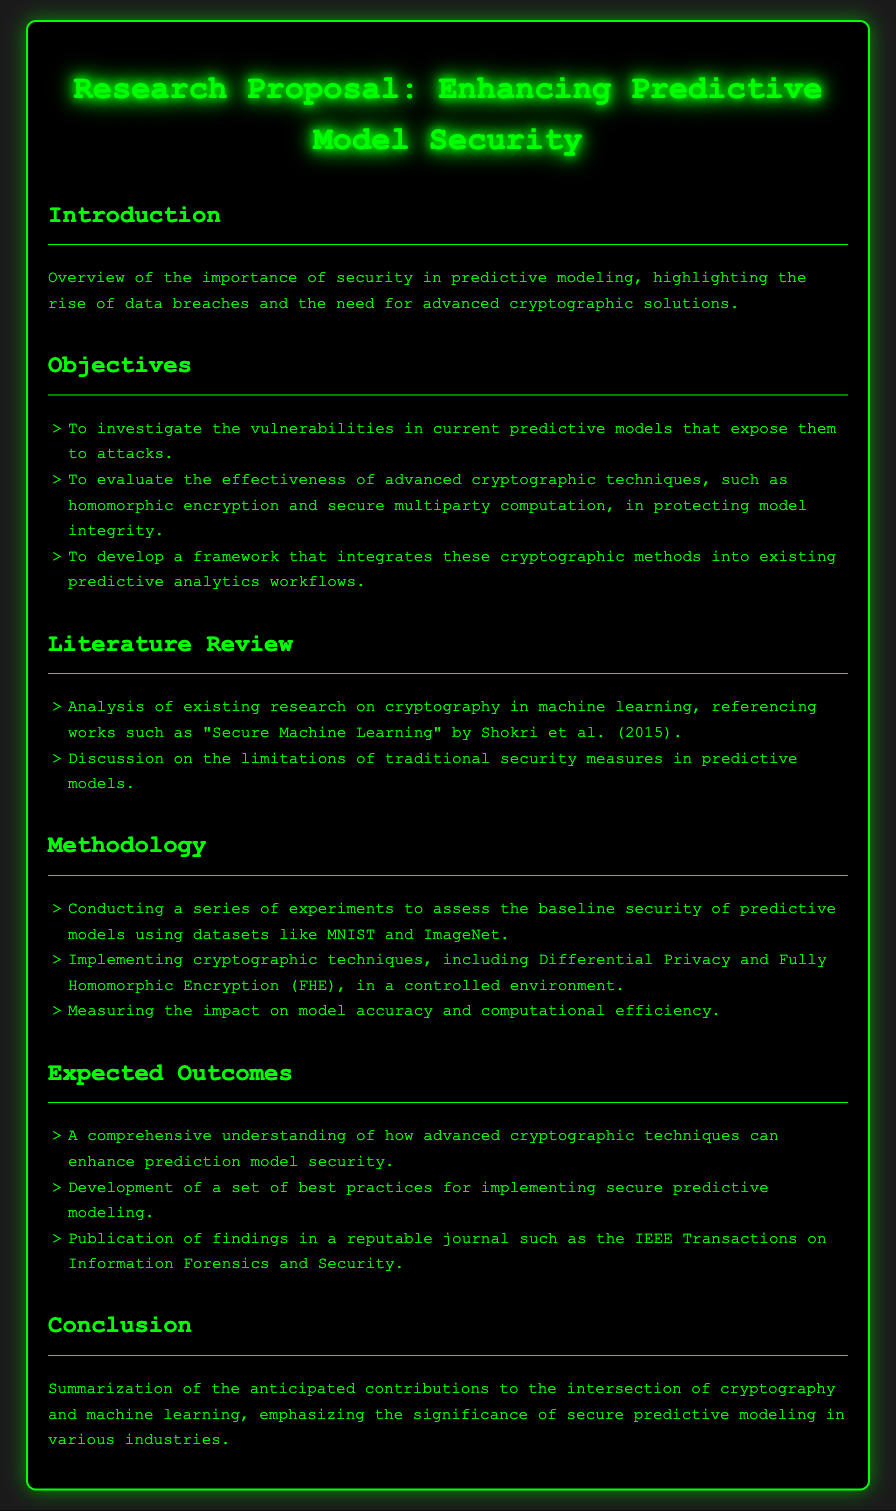What are the three main objectives of the research proposal? The objectives listed in the document include investigating vulnerabilities, evaluating effectiveness of cryptographic techniques, and developing a framework for integration.
Answer: Investigate vulnerabilities, evaluate effectiveness, develop a framework Which advanced cryptographic techniques are mentioned in the proposal? The document states specific techniques that will be evaluated to protect model integrity.
Answer: Homomorphic encryption, secure multiparty computation What datasets will be used in the experiments? The proposal outlines specific datasets for assessing baseline security of predictive models.
Answer: MNIST, ImageNet What is one expected outcome of the research? The document provides details on various results that the research aims to achieve, focusing on the understanding of security enhancements.
Answer: A comprehensive understanding of enhancements Which journal is mentioned for potential publication of findings? The proposal states the intended journal for submitting the research outcomes.
Answer: IEEE Transactions on Information Forensics and Security What is the primary focus of the literature review? The literature review section highlights the analysis conducted on current research and limitations in the field.
Answer: Cryptography in machine learning What methodology involves implementing different cryptographic techniques? The methodology section describes experiments designed to assess model security by using specific cryptographic methods.
Answer: Controlled environment What will be discussed regarding traditional security measures? The document states that the limitations of these measures will be analyzed in the literature review.
Answer: Limitations of traditional security measures 